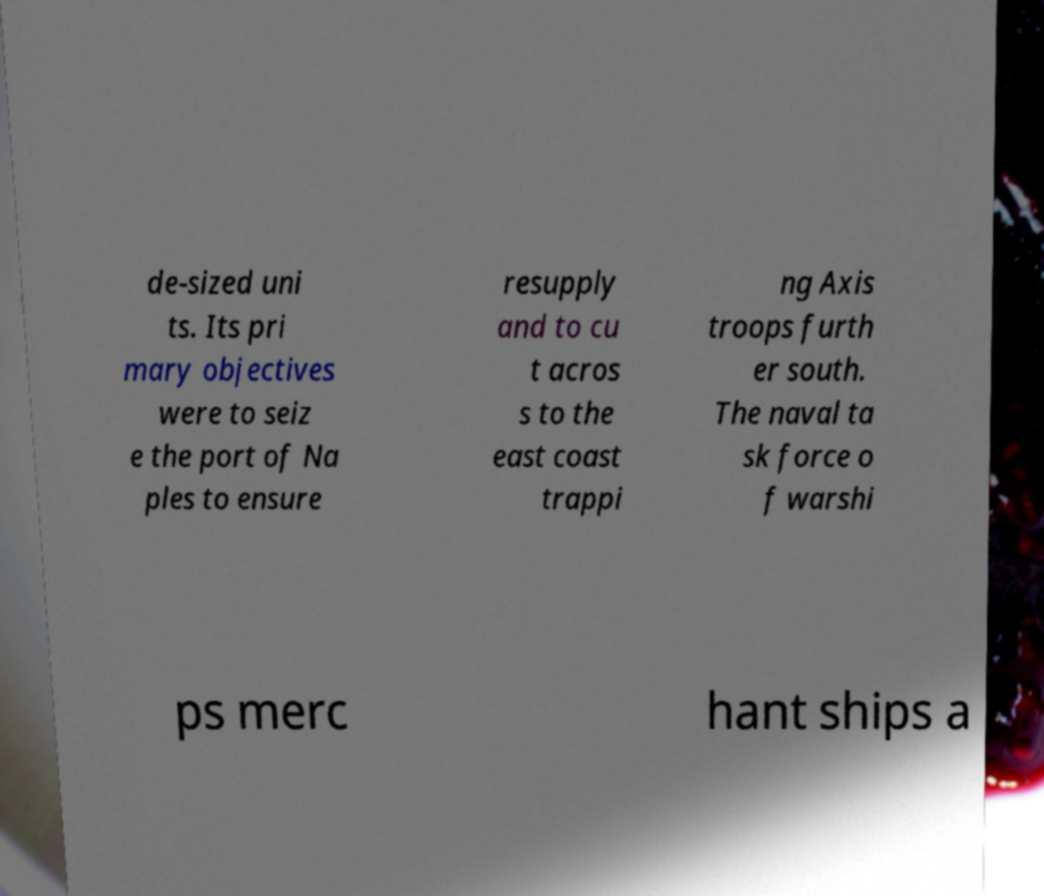Can you read and provide the text displayed in the image?This photo seems to have some interesting text. Can you extract and type it out for me? de-sized uni ts. Its pri mary objectives were to seiz e the port of Na ples to ensure resupply and to cu t acros s to the east coast trappi ng Axis troops furth er south. The naval ta sk force o f warshi ps merc hant ships a 